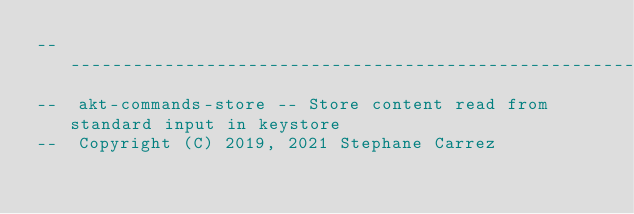<code> <loc_0><loc_0><loc_500><loc_500><_Ada_>-----------------------------------------------------------------------
--  akt-commands-store -- Store content read from standard input in keystore
--  Copyright (C) 2019, 2021 Stephane Carrez</code> 